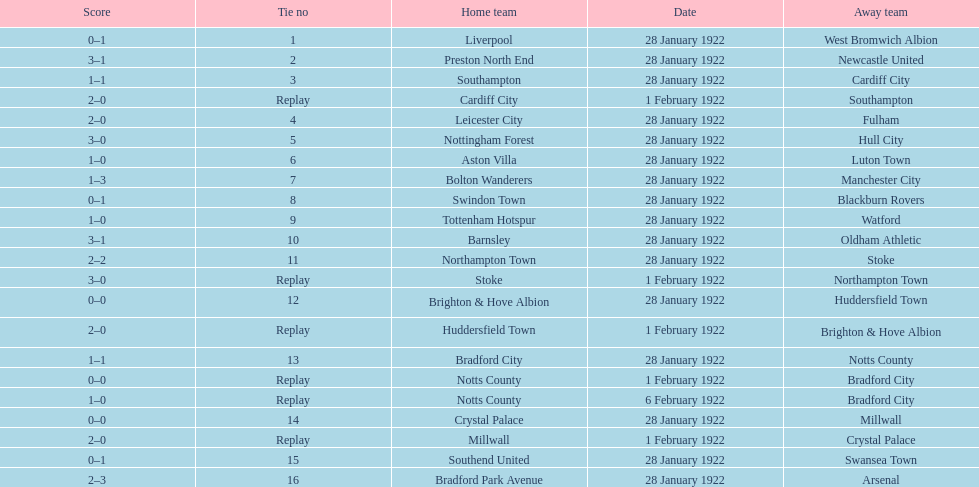How many games had four total points scored or more? 5. 